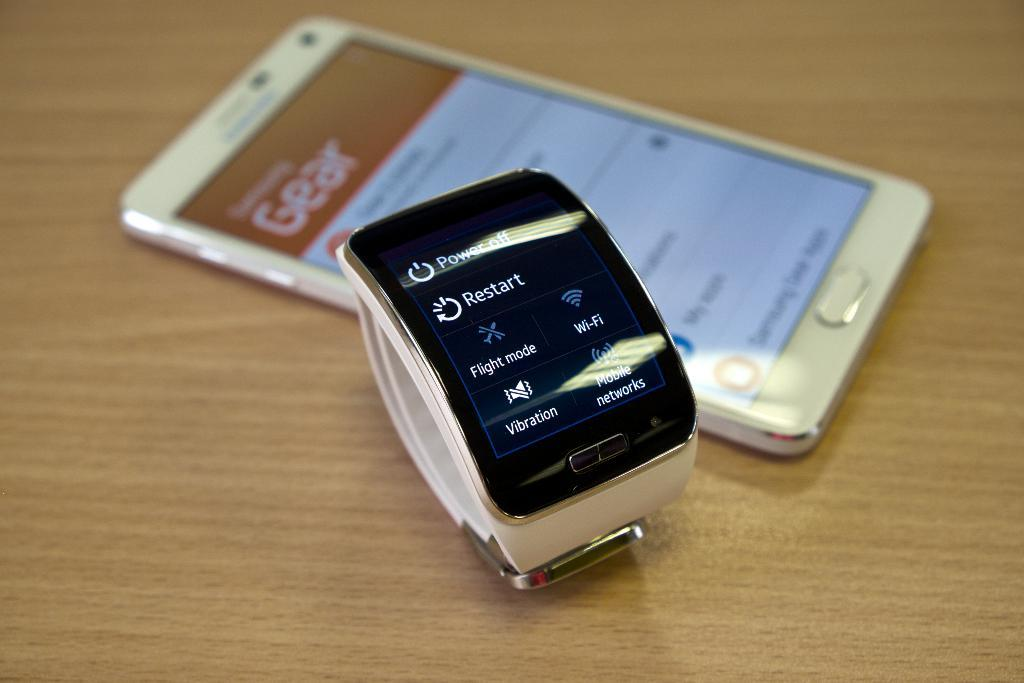<image>
Summarize the visual content of the image. A s face showing selections on a smart watch like Restart 